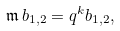<formula> <loc_0><loc_0><loc_500><loc_500>\mathfrak { m } \, b _ { 1 , 2 } = q ^ { k } b _ { 1 , 2 } ,</formula> 